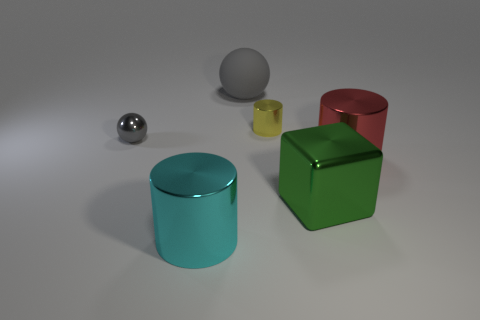Add 1 green shiny cubes. How many objects exist? 7 Subtract all cubes. How many objects are left? 5 Add 1 large green objects. How many large green objects are left? 2 Add 3 large gray spheres. How many large gray spheres exist? 4 Subtract 0 cyan cubes. How many objects are left? 6 Subtract all big red metallic objects. Subtract all red cylinders. How many objects are left? 4 